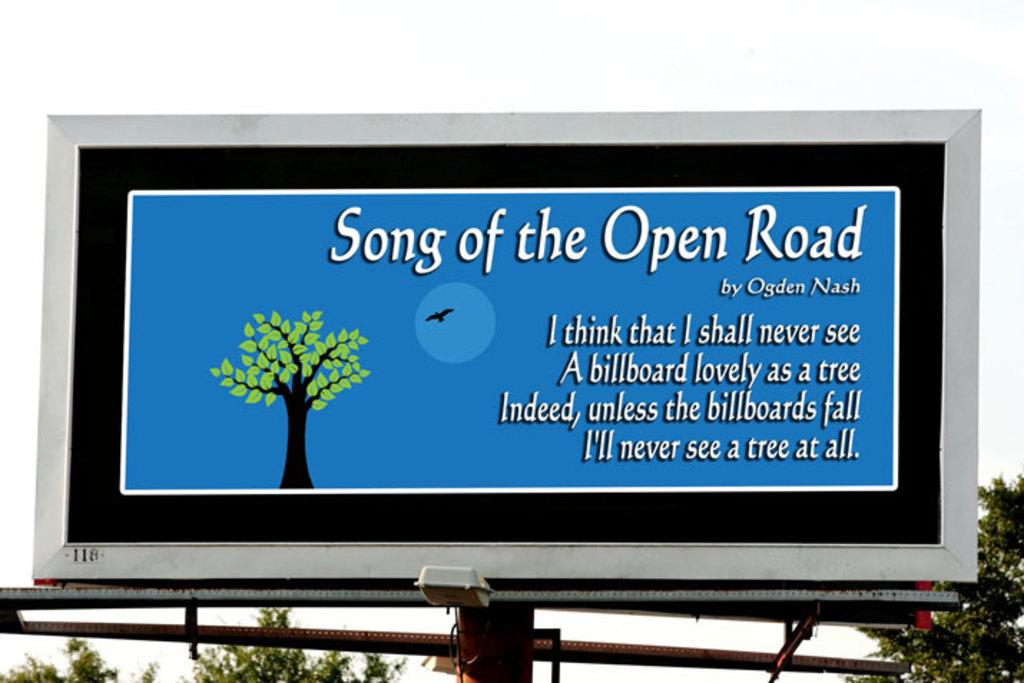<image>
Offer a succinct explanation of the picture presented. A billboard is showing a poem called Song of the Open Road. 